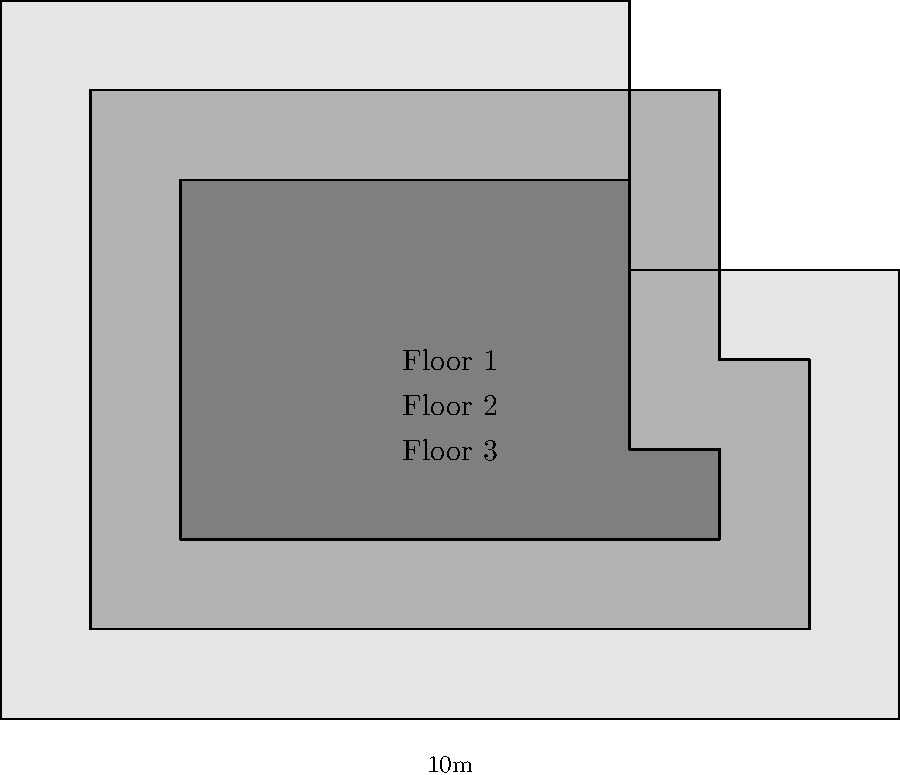A new multi-level laboratory building is being constructed for advanced research in South Africa. The building has an irregular shape with three floors of decreasing size. The dimensions of the first floor are 10m x 8m, with a 3m x 3m section removed from the upper right corner. The second floor is 1m smaller on all sides compared to the first floor, and the third floor is 1m smaller on all sides compared to the second floor. Calculate the total floor area of the building in square meters. Let's calculate the area of each floor separately:

1. First floor:
   Total rectangle: $10m \times 8m = 80m^2$
   Removed section: $3m \times 3m = 9m^2$
   Area of first floor: $80m^2 - 9m^2 = 71m^2$

2. Second floor:
   Length: $10m - 2m = 8m$
   Width: $8m - 2m = 6m$
   Removed section: $2m \times 3m = 6m^2$
   Area of second floor: $(8m \times 6m) - 6m^2 = 48m^2 - 6m^2 = 42m^2$

3. Third floor:
   Length: $8m - 2m = 6m$
   Width: $6m - 2m = 4m$
   Removed section: $1m \times 3m = 3m^2$
   Area of third floor: $(6m \times 4m) - 3m^2 = 24m^2 - 3m^2 = 21m^2$

Total floor area:
$71m^2 + 42m^2 + 21m^2 = 134m^2$
Answer: $134m^2$ 